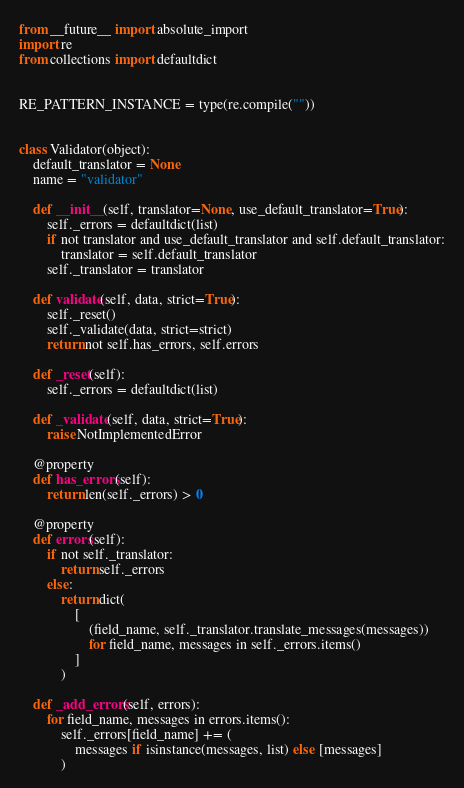<code> <loc_0><loc_0><loc_500><loc_500><_Python_>from __future__ import absolute_import
import re
from collections import defaultdict


RE_PATTERN_INSTANCE = type(re.compile(""))


class Validator(object):
    default_translator = None
    name = "validator"

    def __init__(self, translator=None, use_default_translator=True):
        self._errors = defaultdict(list)
        if not translator and use_default_translator and self.default_translator:
            translator = self.default_translator
        self._translator = translator

    def validate(self, data, strict=True):
        self._reset()
        self._validate(data, strict=strict)
        return not self.has_errors, self.errors

    def _reset(self):
        self._errors = defaultdict(list)

    def _validate(self, data, strict=True):
        raise NotImplementedError

    @property
    def has_errors(self):
        return len(self._errors) > 0

    @property
    def errors(self):
        if not self._translator:
            return self._errors
        else:
            return dict(
                [
                    (field_name, self._translator.translate_messages(messages))
                    for field_name, messages in self._errors.items()
                ]
            )

    def _add_errors(self, errors):
        for field_name, messages in errors.items():
            self._errors[field_name] += (
                messages if isinstance(messages, list) else [messages]
            )
</code> 